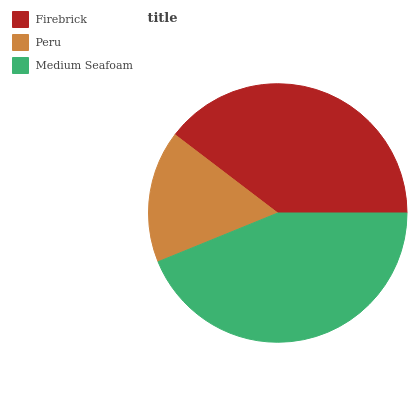Is Peru the minimum?
Answer yes or no. Yes. Is Medium Seafoam the maximum?
Answer yes or no. Yes. Is Medium Seafoam the minimum?
Answer yes or no. No. Is Peru the maximum?
Answer yes or no. No. Is Medium Seafoam greater than Peru?
Answer yes or no. Yes. Is Peru less than Medium Seafoam?
Answer yes or no. Yes. Is Peru greater than Medium Seafoam?
Answer yes or no. No. Is Medium Seafoam less than Peru?
Answer yes or no. No. Is Firebrick the high median?
Answer yes or no. Yes. Is Firebrick the low median?
Answer yes or no. Yes. Is Peru the high median?
Answer yes or no. No. Is Peru the low median?
Answer yes or no. No. 